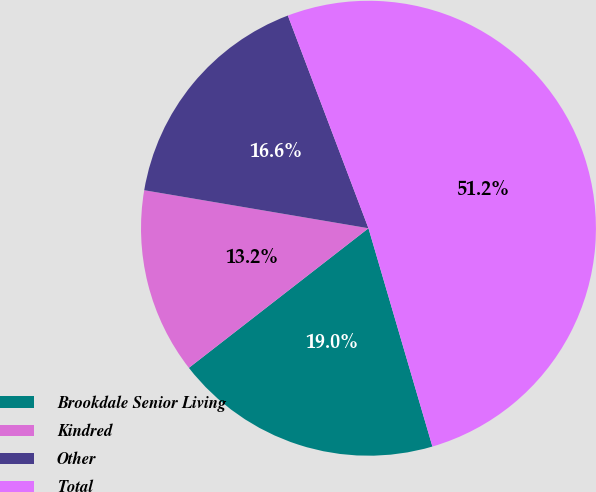Convert chart to OTSL. <chart><loc_0><loc_0><loc_500><loc_500><pie_chart><fcel>Brookdale Senior Living<fcel>Kindred<fcel>Other<fcel>Total<nl><fcel>19.02%<fcel>13.19%<fcel>16.56%<fcel>51.23%<nl></chart> 